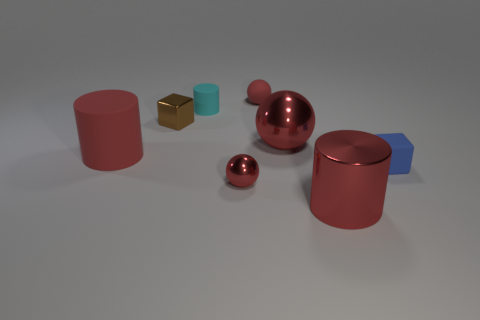What is the shape of the red matte object that is on the left side of the tiny ball behind the small red sphere that is in front of the tiny brown metallic thing?
Offer a terse response. Cylinder. There is a ball that is behind the small cyan object; what is its size?
Your answer should be very brief. Small. What is the shape of the blue matte object that is the same size as the matte ball?
Offer a terse response. Cube. How many objects are big gray shiny spheres or red metallic balls right of the red matte ball?
Give a very brief answer. 1. How many tiny red shiny spheres are left of the tiny red sphere in front of the cube on the right side of the brown metal thing?
Your answer should be very brief. 0. There is a sphere that is made of the same material as the blue block; what color is it?
Your response must be concise. Red. Do the red cylinder to the right of the brown metal object and the small metal sphere have the same size?
Your answer should be very brief. No. How many things are either large cyan metal blocks or red matte spheres?
Your answer should be compact. 1. The tiny thing that is on the right side of the tiny red thing behind the tiny metal thing to the left of the tiny cyan matte thing is made of what material?
Provide a succinct answer. Rubber. There is a object on the right side of the big red shiny cylinder; what material is it?
Give a very brief answer. Rubber. 